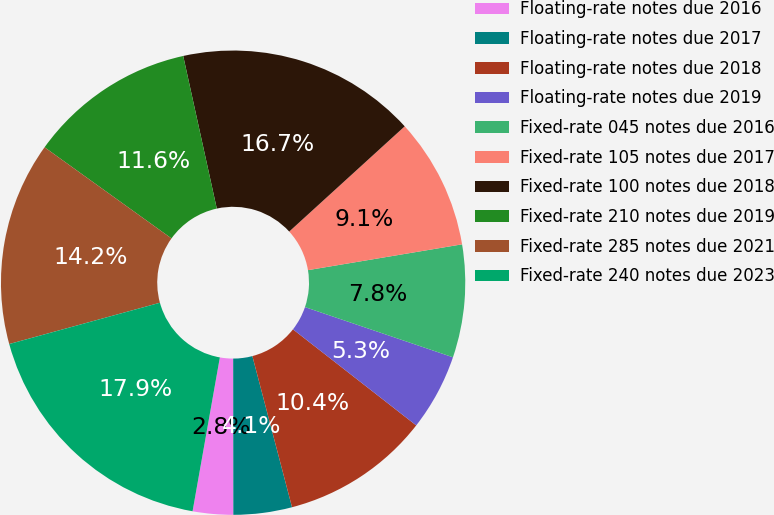Convert chart to OTSL. <chart><loc_0><loc_0><loc_500><loc_500><pie_chart><fcel>Floating-rate notes due 2016<fcel>Floating-rate notes due 2017<fcel>Floating-rate notes due 2018<fcel>Floating-rate notes due 2019<fcel>Fixed-rate 045 notes due 2016<fcel>Fixed-rate 105 notes due 2017<fcel>Fixed-rate 100 notes due 2018<fcel>Fixed-rate 210 notes due 2019<fcel>Fixed-rate 285 notes due 2021<fcel>Fixed-rate 240 notes due 2023<nl><fcel>2.81%<fcel>4.07%<fcel>10.38%<fcel>5.33%<fcel>7.85%<fcel>9.12%<fcel>16.69%<fcel>11.64%<fcel>14.17%<fcel>17.95%<nl></chart> 